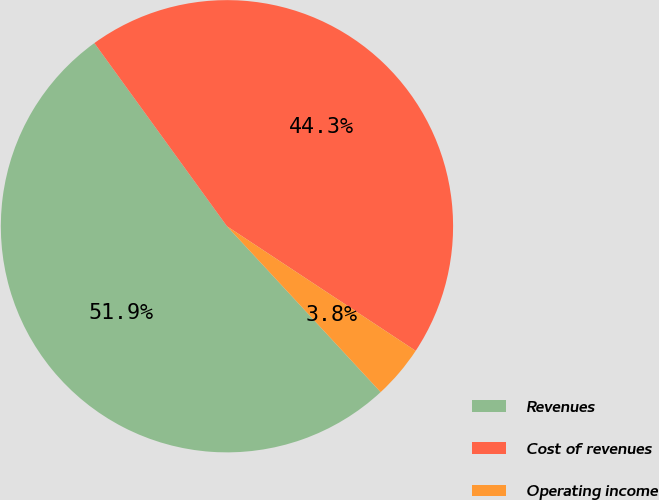Convert chart. <chart><loc_0><loc_0><loc_500><loc_500><pie_chart><fcel>Revenues<fcel>Cost of revenues<fcel>Operating income<nl><fcel>51.92%<fcel>44.26%<fcel>3.82%<nl></chart> 